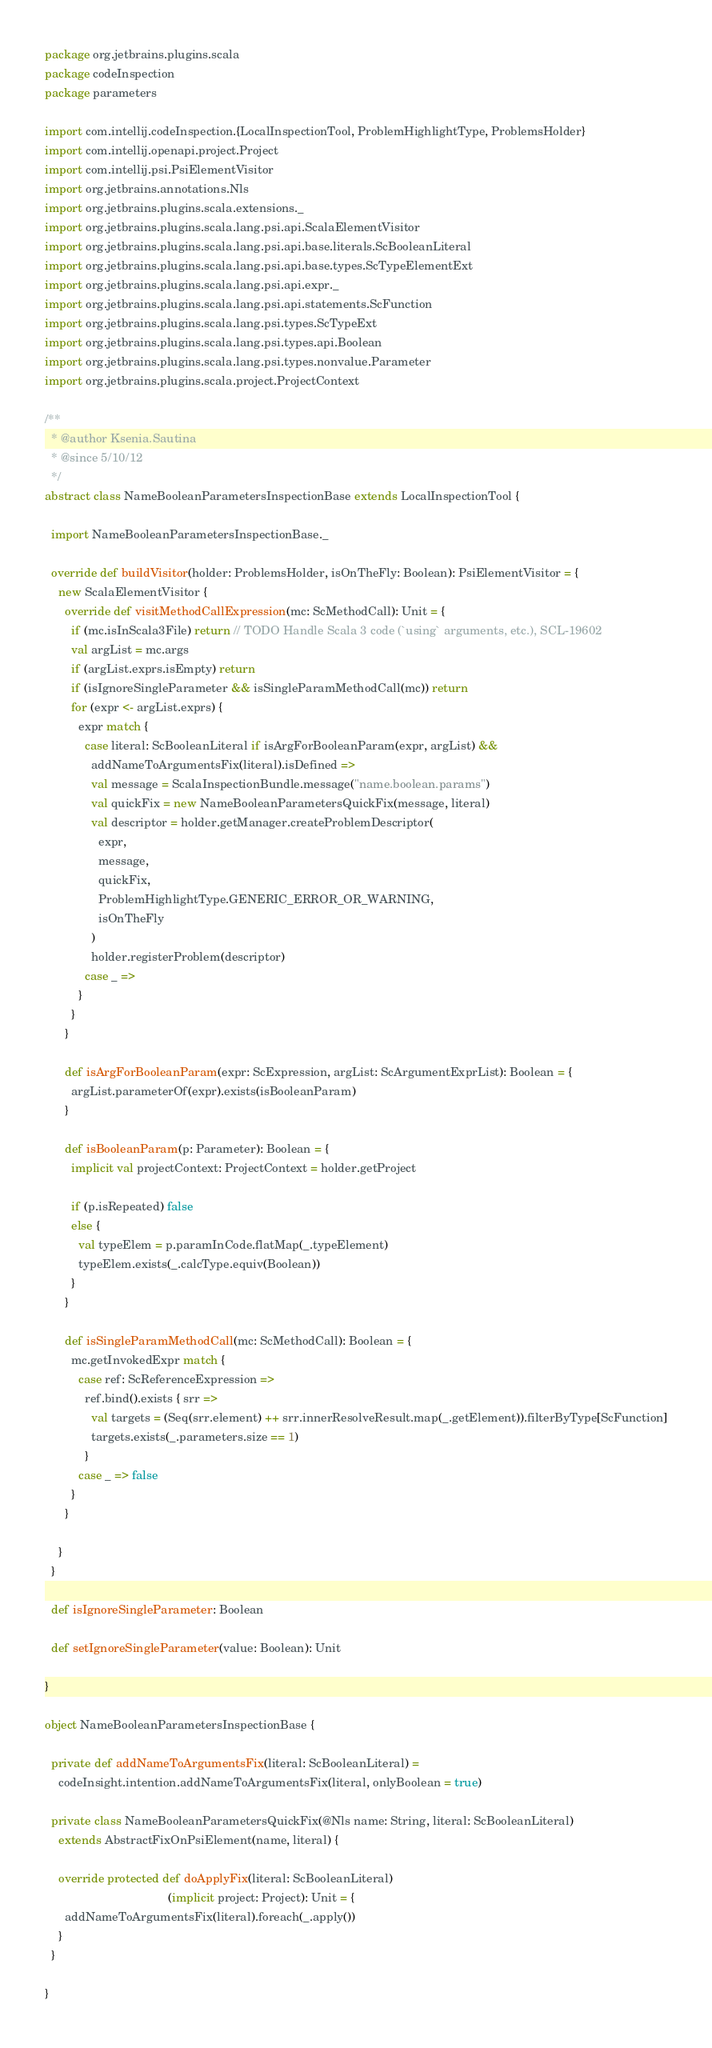Convert code to text. <code><loc_0><loc_0><loc_500><loc_500><_Scala_>package org.jetbrains.plugins.scala
package codeInspection
package parameters

import com.intellij.codeInspection.{LocalInspectionTool, ProblemHighlightType, ProblemsHolder}
import com.intellij.openapi.project.Project
import com.intellij.psi.PsiElementVisitor
import org.jetbrains.annotations.Nls
import org.jetbrains.plugins.scala.extensions._
import org.jetbrains.plugins.scala.lang.psi.api.ScalaElementVisitor
import org.jetbrains.plugins.scala.lang.psi.api.base.literals.ScBooleanLiteral
import org.jetbrains.plugins.scala.lang.psi.api.base.types.ScTypeElementExt
import org.jetbrains.plugins.scala.lang.psi.api.expr._
import org.jetbrains.plugins.scala.lang.psi.api.statements.ScFunction
import org.jetbrains.plugins.scala.lang.psi.types.ScTypeExt
import org.jetbrains.plugins.scala.lang.psi.types.api.Boolean
import org.jetbrains.plugins.scala.lang.psi.types.nonvalue.Parameter
import org.jetbrains.plugins.scala.project.ProjectContext

/**
  * @author Ksenia.Sautina
  * @since 5/10/12
  */
abstract class NameBooleanParametersInspectionBase extends LocalInspectionTool {

  import NameBooleanParametersInspectionBase._

  override def buildVisitor(holder: ProblemsHolder, isOnTheFly: Boolean): PsiElementVisitor = {
    new ScalaElementVisitor {
      override def visitMethodCallExpression(mc: ScMethodCall): Unit = {
        if (mc.isInScala3File) return // TODO Handle Scala 3 code (`using` arguments, etc.), SCL-19602
        val argList = mc.args
        if (argList.exprs.isEmpty) return
        if (isIgnoreSingleParameter && isSingleParamMethodCall(mc)) return
        for (expr <- argList.exprs) {
          expr match {
            case literal: ScBooleanLiteral if isArgForBooleanParam(expr, argList) &&
              addNameToArgumentsFix(literal).isDefined =>
              val message = ScalaInspectionBundle.message("name.boolean.params")
              val quickFix = new NameBooleanParametersQuickFix(message, literal)
              val descriptor = holder.getManager.createProblemDescriptor(
                expr,
                message,
                quickFix,
                ProblemHighlightType.GENERIC_ERROR_OR_WARNING,
                isOnTheFly
              )
              holder.registerProblem(descriptor)
            case _ =>
          }
        }
      }

      def isArgForBooleanParam(expr: ScExpression, argList: ScArgumentExprList): Boolean = {
        argList.parameterOf(expr).exists(isBooleanParam)
      }

      def isBooleanParam(p: Parameter): Boolean = {
        implicit val projectContext: ProjectContext = holder.getProject

        if (p.isRepeated) false
        else {
          val typeElem = p.paramInCode.flatMap(_.typeElement)
          typeElem.exists(_.calcType.equiv(Boolean))
        }
      }

      def isSingleParamMethodCall(mc: ScMethodCall): Boolean = {
        mc.getInvokedExpr match {
          case ref: ScReferenceExpression =>
            ref.bind().exists { srr =>
              val targets = (Seq(srr.element) ++ srr.innerResolveResult.map(_.getElement)).filterByType[ScFunction]
              targets.exists(_.parameters.size == 1)
            }
          case _ => false
        }
      }

    }
  }

  def isIgnoreSingleParameter: Boolean

  def setIgnoreSingleParameter(value: Boolean): Unit

}

object NameBooleanParametersInspectionBase {

  private def addNameToArgumentsFix(literal: ScBooleanLiteral) =
    codeInsight.intention.addNameToArgumentsFix(literal, onlyBoolean = true)

  private class NameBooleanParametersQuickFix(@Nls name: String, literal: ScBooleanLiteral)
    extends AbstractFixOnPsiElement(name, literal) {

    override protected def doApplyFix(literal: ScBooleanLiteral)
                                     (implicit project: Project): Unit = {
      addNameToArgumentsFix(literal).foreach(_.apply())
    }
  }

}</code> 